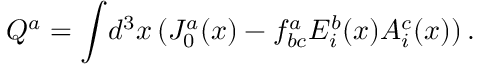<formula> <loc_0><loc_0><loc_500><loc_500>Q ^ { a } = \int \, d ^ { 3 } x \, ( J _ { 0 } ^ { a } ( x ) - f _ { b c } ^ { a } E _ { i } ^ { b } ( x ) A _ { i } ^ { c } ( x ) ) \, .</formula> 